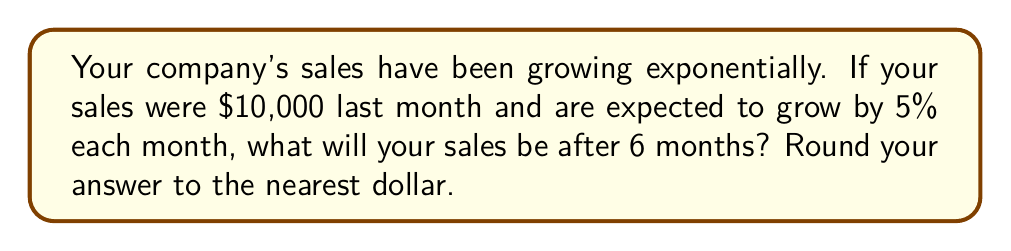Provide a solution to this math problem. Let's approach this step-by-step:

1) We start with an initial sales value of $S_0 = 10000$.

2) The growth rate is 5% per month, which we can express as $r = 0.05$.

3) We want to find the sales after 6 months, so $t = 6$.

4) The exponential growth model is given by the formula:

   $$S(t) = S_0 \cdot (1 + r)^t$$

   Where $S(t)$ is the sales after time $t$, $S_0$ is the initial sales, $r$ is the growth rate, and $t$ is the number of time periods.

5) Plugging in our values:

   $$S(6) = 10000 \cdot (1 + 0.05)^6$$

6) Let's calculate this:

   $$S(6) = 10000 \cdot (1.05)^6$$
   $$S(6) = 10000 \cdot 1.3401$$
   $$S(6) = 13401.00$$

7) Rounding to the nearest dollar:

   $$S(6) \approx 13401$$

Thus, after 6 months, the sales will be approximately $13,401.
Answer: $13,401 